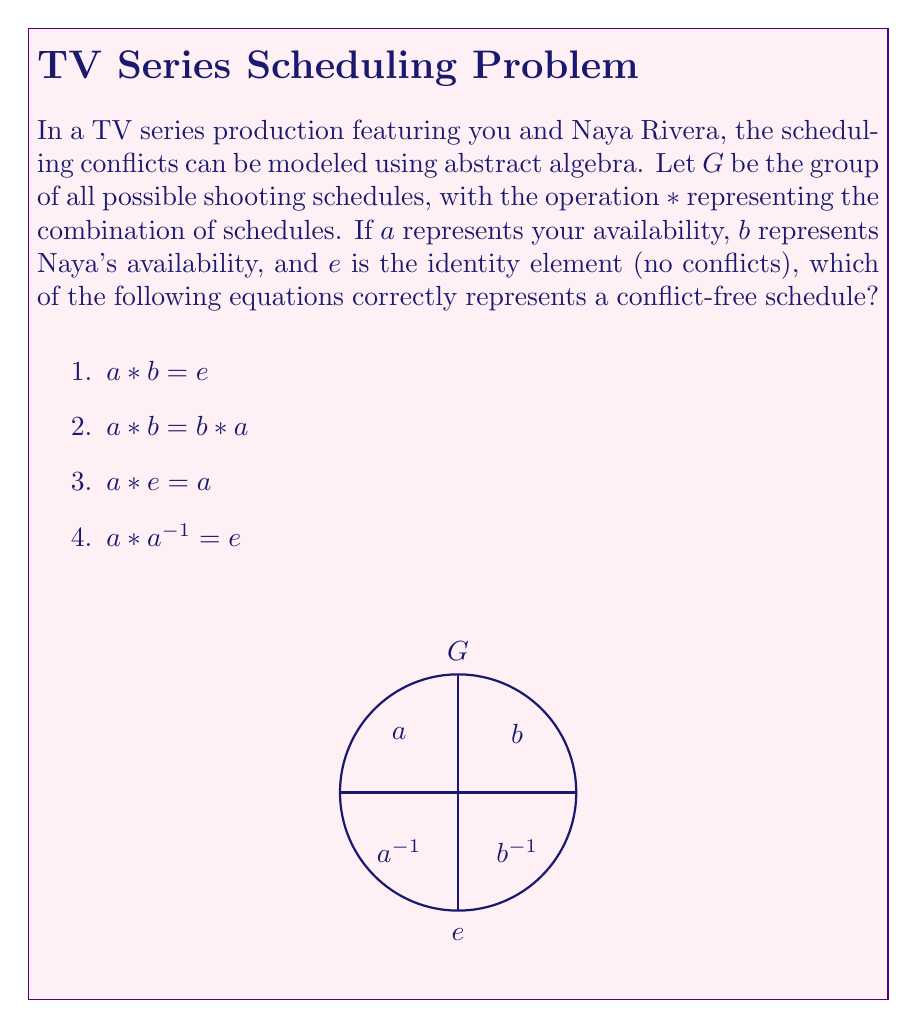Teach me how to tackle this problem. Let's analyze each option step-by-step:

1) $a * b = e$
   This equation suggests that combining your schedule with Naya's results in no conflicts, which is unlikely in a real-world scenario. This is not the correct representation.

2) $a * b = b * a$
   This equation represents the commutative property, meaning the order of combining schedules doesn't matter. While this might be true in some cases, it doesn't necessarily represent a conflict-free schedule.

3) $a * e = a$
   This equation represents the identity property. It states that combining your schedule with no conflicts (e) results in your original schedule. This is always true in group theory and applies to scheduling as well.

4) $a * a^{-1} = e$
   This equation represents the inverse property. It states that combining your schedule with its inverse results in no conflicts. While this is a fundamental property in group theory, it doesn't directly represent a conflict-free schedule between you and Naya.

The correct representation of a conflict-free schedule is option 3: $a * e = a$. This equation shows that your schedule remains unchanged when combined with a schedule with no conflicts, which is the definition of a conflict-free situation in this abstract algebra model.
Answer: $a * e = a$ 